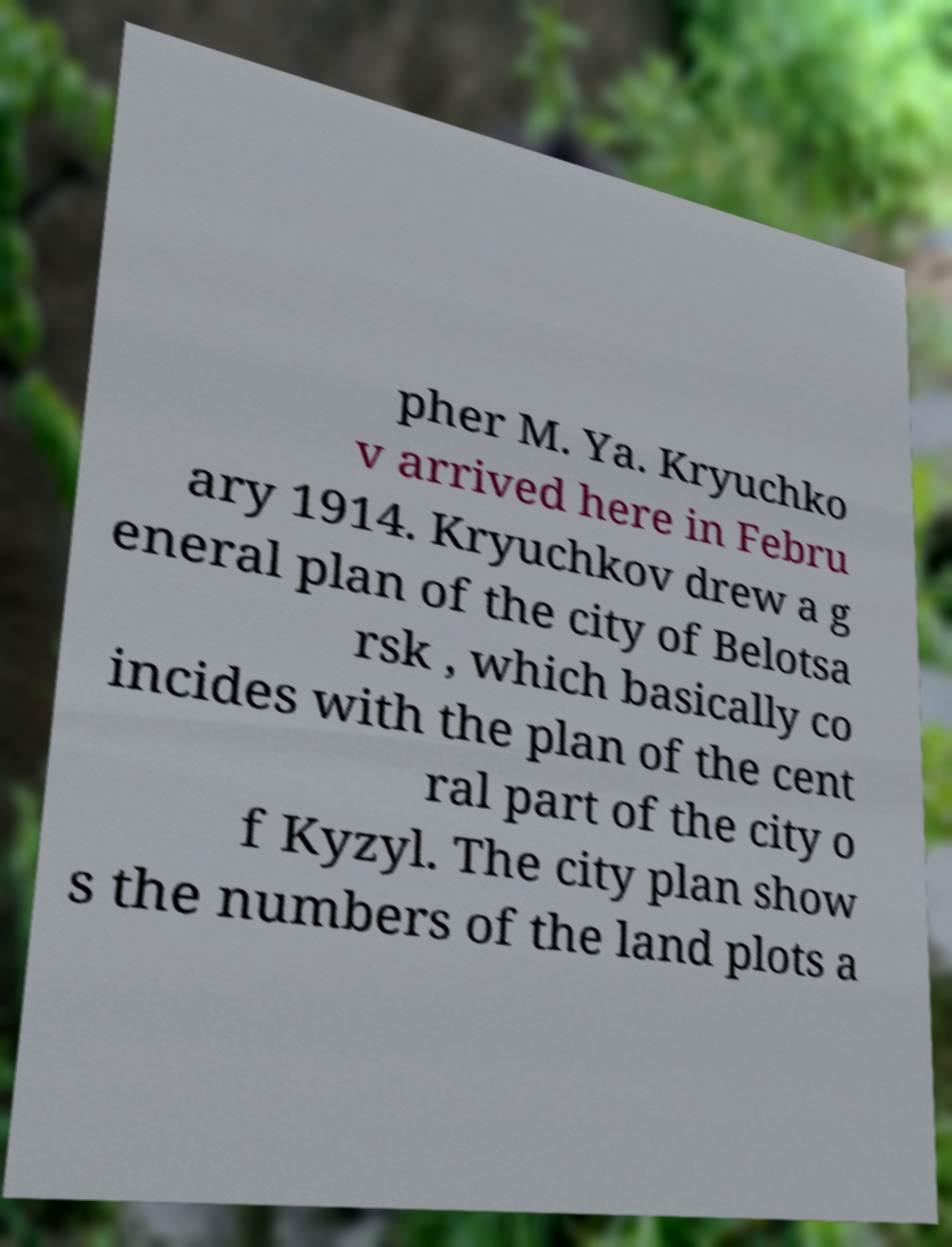For documentation purposes, I need the text within this image transcribed. Could you provide that? pher M. Ya. Kryuchko v arrived here in Febru ary 1914. Kryuchkov drew a g eneral plan of the city of Belotsa rsk , which basically co incides with the plan of the cent ral part of the city o f Kyzyl. The city plan show s the numbers of the land plots a 